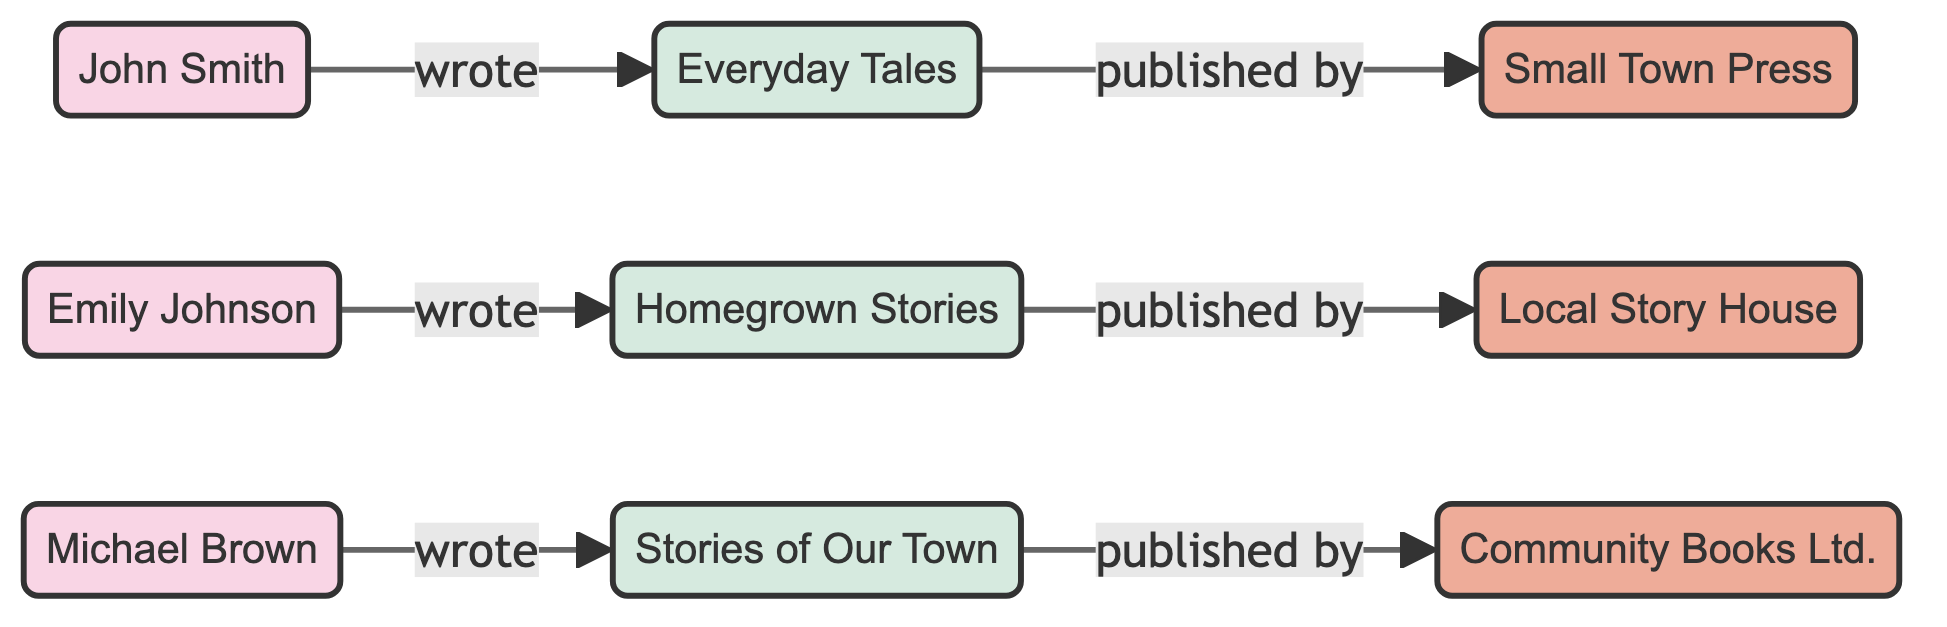What are the names of the authors in the diagram? The diagram includes three authors. By examining the nodes labeled as "author," the names listed are John Smith, Emily Johnson, and Michael Brown.
Answer: John Smith, Emily Johnson, Michael Brown How many publishers are connected to the books? There are three publishers represented in the diagram, each associated with one of the books through the "published by" relationship. The publishers are Small Town Press, Local Story House, and Community Books Ltd.
Answer: 3 Which book was written by Emily Johnson? To find the book Emily Johnson wrote, we check the edges connected to her node. The edge shows that she wrote "Homegrown Stories."
Answer: Homegrown Stories What type of relationship connects authors to their books? The edge connecting authors to books has a label "wrote," indicating that the relationship represents authorship. This can be verified by looking at the edges from the authors to the corresponding books.
Answer: wrote Which publisher is associated with "Everyday Tales"? The diagram shows that "Everyday Tales" has a direct edge to Small Town Press, indicating that this is the publisher for that book.
Answer: Small Town Press How many edges are present in the diagram? By examining the connections in the diagram, we can count that there are a total of six edges representing both authorship and publishing relationships. These connections include three authors writing three books and each book being published by a separate publisher.
Answer: 6 Which book is published by Community Books Ltd.? The connection from the book node in the diagram shows "Stories of Our Town" linked to the publisher "Community Books Ltd.," indicating this is the book published by that particular publisher.
Answer: Stories of Our Town Who wrote "Everyday Tales"? To find the author of "Everyday Tales," we look for the edge originating from the node labeled "Everyday Tales." The edge indicates that John Smith is the author of this book.
Answer: John Smith 